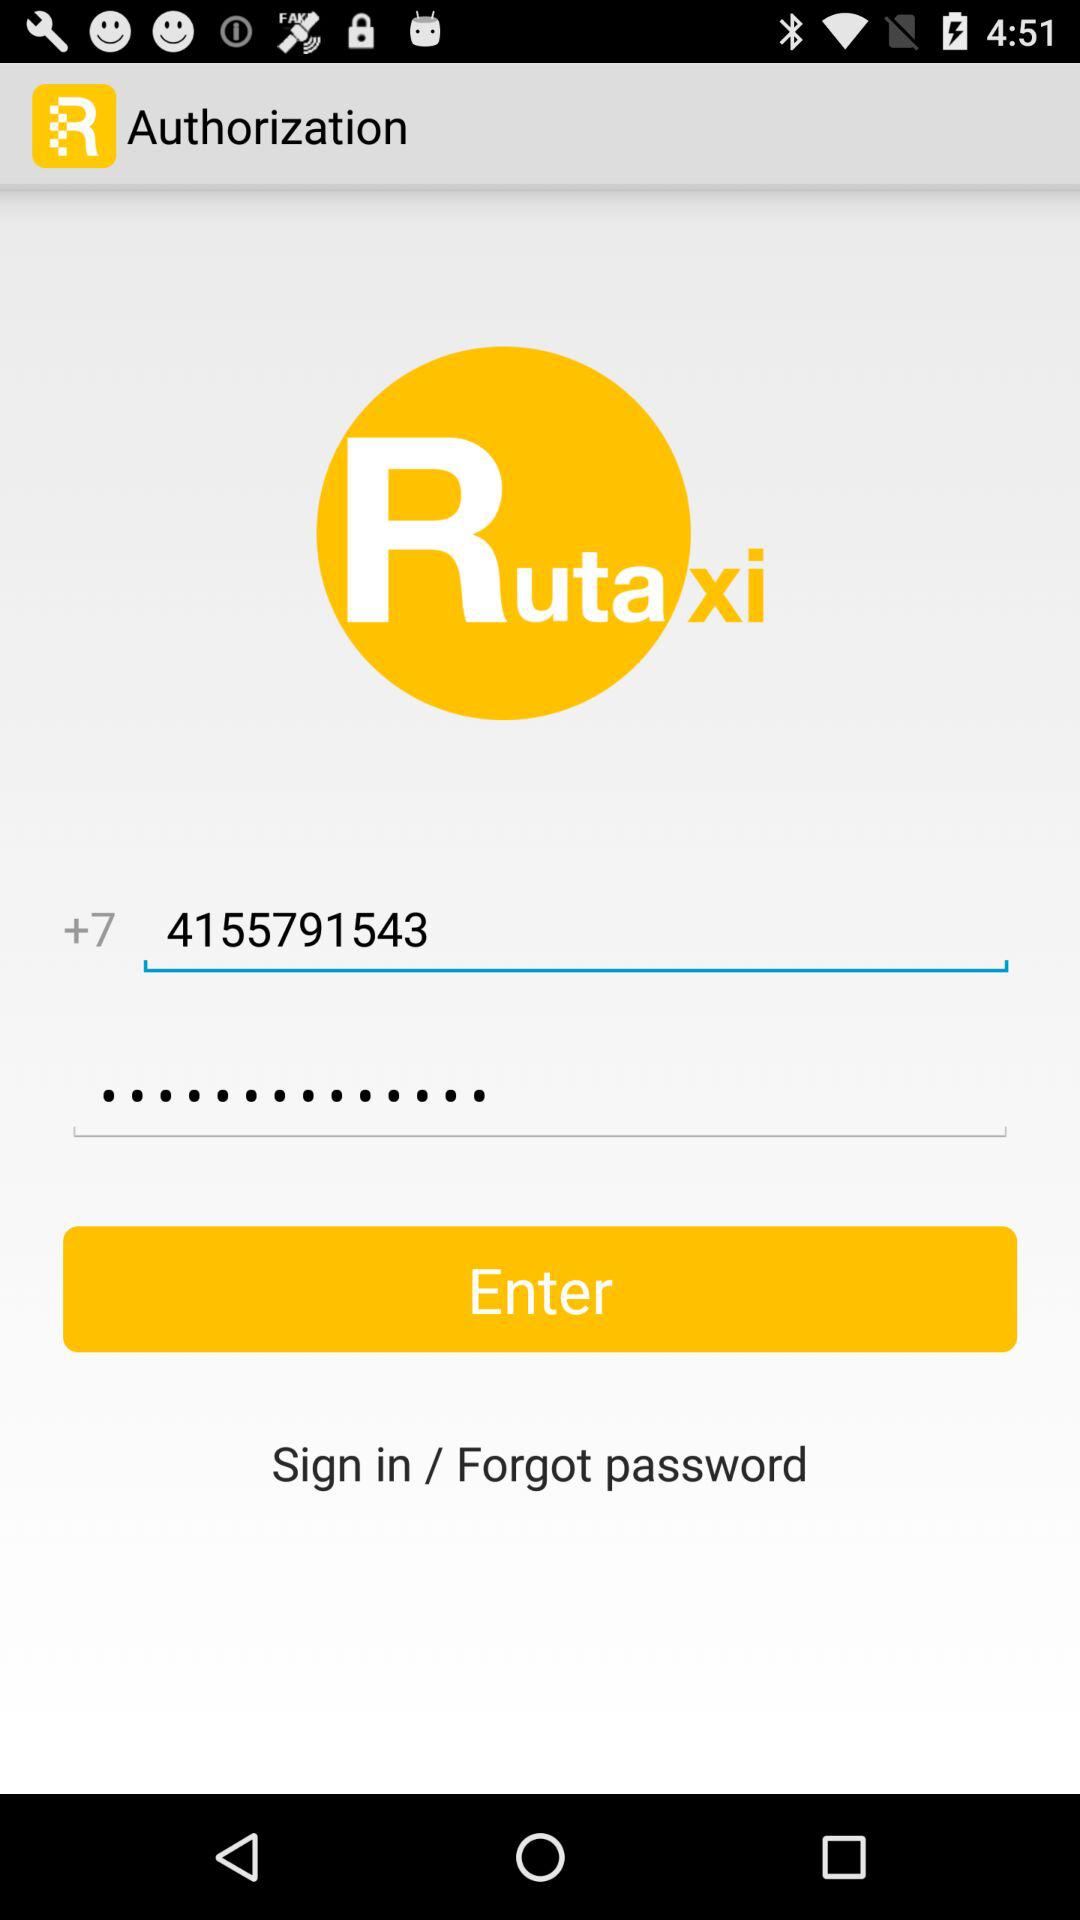What number is used to sign in? The number is 4155791543. 